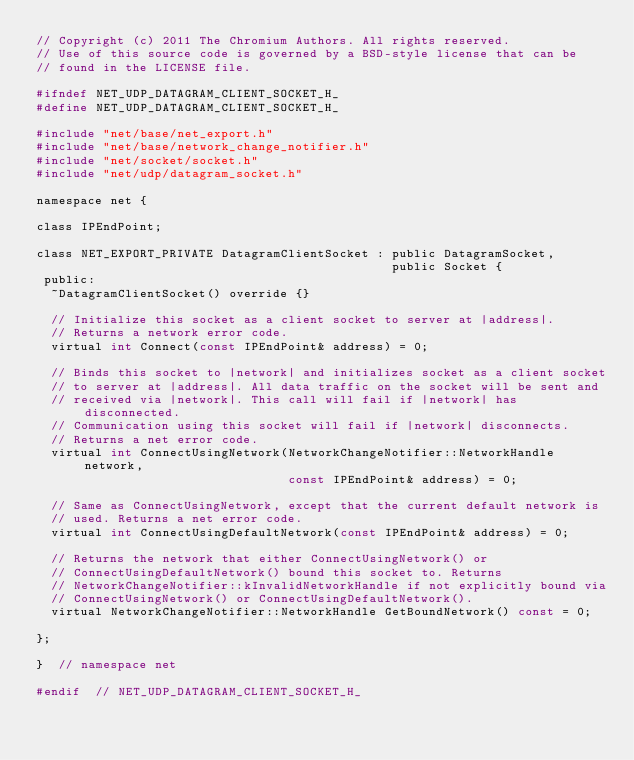<code> <loc_0><loc_0><loc_500><loc_500><_C_>// Copyright (c) 2011 The Chromium Authors. All rights reserved.
// Use of this source code is governed by a BSD-style license that can be
// found in the LICENSE file.

#ifndef NET_UDP_DATAGRAM_CLIENT_SOCKET_H_
#define NET_UDP_DATAGRAM_CLIENT_SOCKET_H_

#include "net/base/net_export.h"
#include "net/base/network_change_notifier.h"
#include "net/socket/socket.h"
#include "net/udp/datagram_socket.h"

namespace net {

class IPEndPoint;

class NET_EXPORT_PRIVATE DatagramClientSocket : public DatagramSocket,
                                                public Socket {
 public:
  ~DatagramClientSocket() override {}

  // Initialize this socket as a client socket to server at |address|.
  // Returns a network error code.
  virtual int Connect(const IPEndPoint& address) = 0;

  // Binds this socket to |network| and initializes socket as a client socket
  // to server at |address|. All data traffic on the socket will be sent and
  // received via |network|. This call will fail if |network| has disconnected.
  // Communication using this socket will fail if |network| disconnects.
  // Returns a net error code.
  virtual int ConnectUsingNetwork(NetworkChangeNotifier::NetworkHandle network,
                                  const IPEndPoint& address) = 0;

  // Same as ConnectUsingNetwork, except that the current default network is
  // used. Returns a net error code.
  virtual int ConnectUsingDefaultNetwork(const IPEndPoint& address) = 0;

  // Returns the network that either ConnectUsingNetwork() or
  // ConnectUsingDefaultNetwork() bound this socket to. Returns
  // NetworkChangeNotifier::kInvalidNetworkHandle if not explicitly bound via
  // ConnectUsingNetwork() or ConnectUsingDefaultNetwork().
  virtual NetworkChangeNotifier::NetworkHandle GetBoundNetwork() const = 0;

};

}  // namespace net

#endif  // NET_UDP_DATAGRAM_CLIENT_SOCKET_H_
</code> 